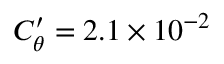<formula> <loc_0><loc_0><loc_500><loc_500>C _ { \theta } ^ { \prime } = 2 . 1 \times 1 0 ^ { - 2 }</formula> 